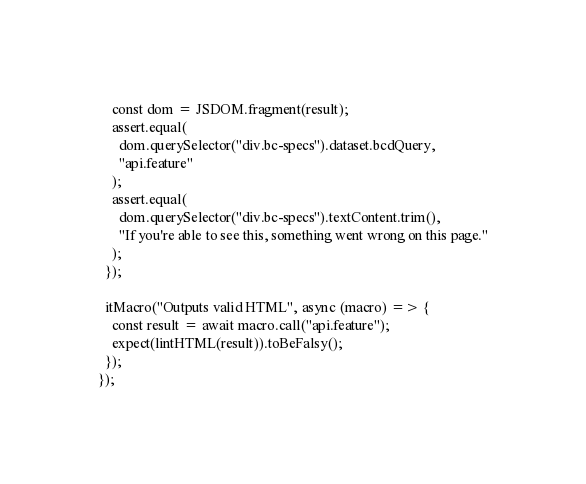Convert code to text. <code><loc_0><loc_0><loc_500><loc_500><_JavaScript_>    const dom = JSDOM.fragment(result);
    assert.equal(
      dom.querySelector("div.bc-specs").dataset.bcdQuery,
      "api.feature"
    );
    assert.equal(
      dom.querySelector("div.bc-specs").textContent.trim(),
      "If you're able to see this, something went wrong on this page."
    );
  });

  itMacro("Outputs valid HTML", async (macro) => {
    const result = await macro.call("api.feature");
    expect(lintHTML(result)).toBeFalsy();
  });
});
</code> 